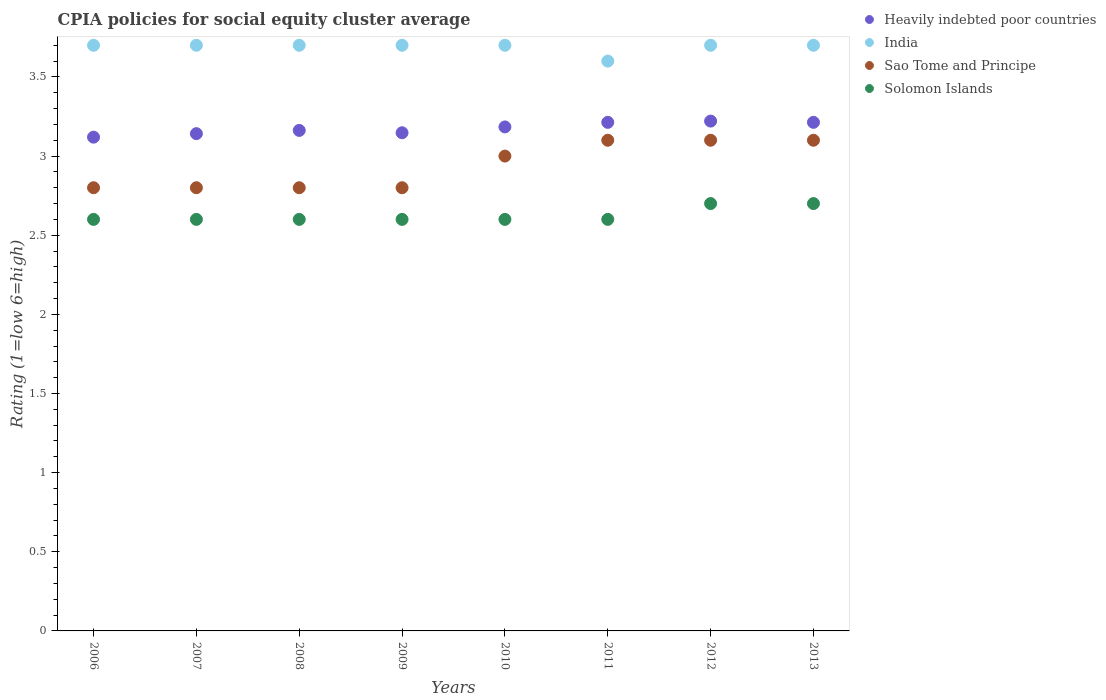Is the number of dotlines equal to the number of legend labels?
Your answer should be very brief. Yes. Across all years, what is the maximum CPIA rating in Heavily indebted poor countries?
Provide a succinct answer. 3.22. Across all years, what is the minimum CPIA rating in Solomon Islands?
Make the answer very short. 2.6. In which year was the CPIA rating in Heavily indebted poor countries maximum?
Your answer should be compact. 2012. What is the total CPIA rating in Solomon Islands in the graph?
Provide a short and direct response. 21. What is the difference between the CPIA rating in Solomon Islands in 2007 and that in 2011?
Your answer should be compact. 0. What is the difference between the CPIA rating in Sao Tome and Principe in 2011 and the CPIA rating in Solomon Islands in 2012?
Your answer should be very brief. 0.4. What is the average CPIA rating in India per year?
Offer a terse response. 3.69. In the year 2012, what is the difference between the CPIA rating in Solomon Islands and CPIA rating in Heavily indebted poor countries?
Your response must be concise. -0.52. What is the ratio of the CPIA rating in Sao Tome and Principe in 2008 to that in 2012?
Keep it short and to the point. 0.9. Is the CPIA rating in Sao Tome and Principe in 2009 less than that in 2013?
Provide a short and direct response. Yes. Is the difference between the CPIA rating in Solomon Islands in 2008 and 2011 greater than the difference between the CPIA rating in Heavily indebted poor countries in 2008 and 2011?
Keep it short and to the point. Yes. What is the difference between the highest and the lowest CPIA rating in Sao Tome and Principe?
Offer a terse response. 0.3. Is it the case that in every year, the sum of the CPIA rating in Solomon Islands and CPIA rating in India  is greater than the sum of CPIA rating in Sao Tome and Principe and CPIA rating in Heavily indebted poor countries?
Ensure brevity in your answer.  No. Is it the case that in every year, the sum of the CPIA rating in India and CPIA rating in Solomon Islands  is greater than the CPIA rating in Sao Tome and Principe?
Offer a terse response. Yes. Does the CPIA rating in Sao Tome and Principe monotonically increase over the years?
Your answer should be very brief. No. How many dotlines are there?
Offer a very short reply. 4. How many years are there in the graph?
Keep it short and to the point. 8. What is the difference between two consecutive major ticks on the Y-axis?
Keep it short and to the point. 0.5. How many legend labels are there?
Your answer should be very brief. 4. What is the title of the graph?
Give a very brief answer. CPIA policies for social equity cluster average. What is the label or title of the X-axis?
Provide a succinct answer. Years. What is the Rating (1=low 6=high) in Heavily indebted poor countries in 2006?
Ensure brevity in your answer.  3.12. What is the Rating (1=low 6=high) in Sao Tome and Principe in 2006?
Keep it short and to the point. 2.8. What is the Rating (1=low 6=high) of Heavily indebted poor countries in 2007?
Your response must be concise. 3.14. What is the Rating (1=low 6=high) in India in 2007?
Your response must be concise. 3.7. What is the Rating (1=low 6=high) in Solomon Islands in 2007?
Your response must be concise. 2.6. What is the Rating (1=low 6=high) of Heavily indebted poor countries in 2008?
Your answer should be very brief. 3.16. What is the Rating (1=low 6=high) of India in 2008?
Make the answer very short. 3.7. What is the Rating (1=low 6=high) of Sao Tome and Principe in 2008?
Give a very brief answer. 2.8. What is the Rating (1=low 6=high) in Solomon Islands in 2008?
Offer a terse response. 2.6. What is the Rating (1=low 6=high) in Heavily indebted poor countries in 2009?
Your answer should be compact. 3.15. What is the Rating (1=low 6=high) of Heavily indebted poor countries in 2010?
Offer a terse response. 3.18. What is the Rating (1=low 6=high) in Sao Tome and Principe in 2010?
Give a very brief answer. 3. What is the Rating (1=low 6=high) of Heavily indebted poor countries in 2011?
Provide a short and direct response. 3.21. What is the Rating (1=low 6=high) in India in 2011?
Keep it short and to the point. 3.6. What is the Rating (1=low 6=high) of Sao Tome and Principe in 2011?
Your response must be concise. 3.1. What is the Rating (1=low 6=high) in Heavily indebted poor countries in 2012?
Provide a succinct answer. 3.22. What is the Rating (1=low 6=high) of India in 2012?
Ensure brevity in your answer.  3.7. What is the Rating (1=low 6=high) in Heavily indebted poor countries in 2013?
Your answer should be very brief. 3.21. What is the Rating (1=low 6=high) of India in 2013?
Offer a terse response. 3.7. What is the Rating (1=low 6=high) of Sao Tome and Principe in 2013?
Ensure brevity in your answer.  3.1. Across all years, what is the maximum Rating (1=low 6=high) of Heavily indebted poor countries?
Keep it short and to the point. 3.22. Across all years, what is the maximum Rating (1=low 6=high) in India?
Provide a short and direct response. 3.7. Across all years, what is the maximum Rating (1=low 6=high) in Sao Tome and Principe?
Offer a terse response. 3.1. Across all years, what is the maximum Rating (1=low 6=high) of Solomon Islands?
Provide a short and direct response. 2.7. Across all years, what is the minimum Rating (1=low 6=high) of Heavily indebted poor countries?
Offer a terse response. 3.12. Across all years, what is the minimum Rating (1=low 6=high) in India?
Keep it short and to the point. 3.6. Across all years, what is the minimum Rating (1=low 6=high) in Sao Tome and Principe?
Your answer should be very brief. 2.8. What is the total Rating (1=low 6=high) of Heavily indebted poor countries in the graph?
Your answer should be very brief. 25.4. What is the total Rating (1=low 6=high) of India in the graph?
Keep it short and to the point. 29.5. What is the total Rating (1=low 6=high) of Sao Tome and Principe in the graph?
Make the answer very short. 23.5. What is the total Rating (1=low 6=high) of Solomon Islands in the graph?
Ensure brevity in your answer.  21. What is the difference between the Rating (1=low 6=high) in Heavily indebted poor countries in 2006 and that in 2007?
Make the answer very short. -0.02. What is the difference between the Rating (1=low 6=high) in Solomon Islands in 2006 and that in 2007?
Make the answer very short. 0. What is the difference between the Rating (1=low 6=high) of Heavily indebted poor countries in 2006 and that in 2008?
Offer a very short reply. -0.04. What is the difference between the Rating (1=low 6=high) in Solomon Islands in 2006 and that in 2008?
Your answer should be very brief. 0. What is the difference between the Rating (1=low 6=high) of Heavily indebted poor countries in 2006 and that in 2009?
Keep it short and to the point. -0.03. What is the difference between the Rating (1=low 6=high) in Heavily indebted poor countries in 2006 and that in 2010?
Offer a very short reply. -0.06. What is the difference between the Rating (1=low 6=high) in India in 2006 and that in 2010?
Offer a very short reply. 0. What is the difference between the Rating (1=low 6=high) in Heavily indebted poor countries in 2006 and that in 2011?
Make the answer very short. -0.09. What is the difference between the Rating (1=low 6=high) of Heavily indebted poor countries in 2006 and that in 2012?
Your response must be concise. -0.1. What is the difference between the Rating (1=low 6=high) of Sao Tome and Principe in 2006 and that in 2012?
Ensure brevity in your answer.  -0.3. What is the difference between the Rating (1=low 6=high) in Solomon Islands in 2006 and that in 2012?
Provide a short and direct response. -0.1. What is the difference between the Rating (1=low 6=high) in Heavily indebted poor countries in 2006 and that in 2013?
Offer a very short reply. -0.09. What is the difference between the Rating (1=low 6=high) in India in 2006 and that in 2013?
Your answer should be compact. 0. What is the difference between the Rating (1=low 6=high) of Heavily indebted poor countries in 2007 and that in 2008?
Offer a terse response. -0.02. What is the difference between the Rating (1=low 6=high) of India in 2007 and that in 2008?
Your answer should be compact. 0. What is the difference between the Rating (1=low 6=high) in Solomon Islands in 2007 and that in 2008?
Offer a very short reply. 0. What is the difference between the Rating (1=low 6=high) of Heavily indebted poor countries in 2007 and that in 2009?
Your response must be concise. -0.01. What is the difference between the Rating (1=low 6=high) of India in 2007 and that in 2009?
Your response must be concise. 0. What is the difference between the Rating (1=low 6=high) of Sao Tome and Principe in 2007 and that in 2009?
Keep it short and to the point. 0. What is the difference between the Rating (1=low 6=high) of Solomon Islands in 2007 and that in 2009?
Offer a very short reply. 0. What is the difference between the Rating (1=low 6=high) in Heavily indebted poor countries in 2007 and that in 2010?
Give a very brief answer. -0.04. What is the difference between the Rating (1=low 6=high) in India in 2007 and that in 2010?
Provide a succinct answer. 0. What is the difference between the Rating (1=low 6=high) of Sao Tome and Principe in 2007 and that in 2010?
Offer a terse response. -0.2. What is the difference between the Rating (1=low 6=high) in Solomon Islands in 2007 and that in 2010?
Keep it short and to the point. 0. What is the difference between the Rating (1=low 6=high) in Heavily indebted poor countries in 2007 and that in 2011?
Keep it short and to the point. -0.07. What is the difference between the Rating (1=low 6=high) in Sao Tome and Principe in 2007 and that in 2011?
Ensure brevity in your answer.  -0.3. What is the difference between the Rating (1=low 6=high) in Solomon Islands in 2007 and that in 2011?
Your response must be concise. 0. What is the difference between the Rating (1=low 6=high) in Heavily indebted poor countries in 2007 and that in 2012?
Offer a terse response. -0.08. What is the difference between the Rating (1=low 6=high) of Sao Tome and Principe in 2007 and that in 2012?
Your answer should be compact. -0.3. What is the difference between the Rating (1=low 6=high) in Heavily indebted poor countries in 2007 and that in 2013?
Offer a very short reply. -0.07. What is the difference between the Rating (1=low 6=high) of India in 2007 and that in 2013?
Give a very brief answer. 0. What is the difference between the Rating (1=low 6=high) in Sao Tome and Principe in 2007 and that in 2013?
Provide a succinct answer. -0.3. What is the difference between the Rating (1=low 6=high) in Solomon Islands in 2007 and that in 2013?
Provide a short and direct response. -0.1. What is the difference between the Rating (1=low 6=high) in Heavily indebted poor countries in 2008 and that in 2009?
Keep it short and to the point. 0.01. What is the difference between the Rating (1=low 6=high) of India in 2008 and that in 2009?
Give a very brief answer. 0. What is the difference between the Rating (1=low 6=high) of Sao Tome and Principe in 2008 and that in 2009?
Offer a terse response. 0. What is the difference between the Rating (1=low 6=high) in Solomon Islands in 2008 and that in 2009?
Provide a succinct answer. 0. What is the difference between the Rating (1=low 6=high) of Heavily indebted poor countries in 2008 and that in 2010?
Provide a succinct answer. -0.02. What is the difference between the Rating (1=low 6=high) of Sao Tome and Principe in 2008 and that in 2010?
Give a very brief answer. -0.2. What is the difference between the Rating (1=low 6=high) in Heavily indebted poor countries in 2008 and that in 2011?
Offer a terse response. -0.05. What is the difference between the Rating (1=low 6=high) in India in 2008 and that in 2011?
Make the answer very short. 0.1. What is the difference between the Rating (1=low 6=high) in Heavily indebted poor countries in 2008 and that in 2012?
Offer a very short reply. -0.06. What is the difference between the Rating (1=low 6=high) in Heavily indebted poor countries in 2008 and that in 2013?
Your response must be concise. -0.05. What is the difference between the Rating (1=low 6=high) in India in 2008 and that in 2013?
Offer a very short reply. 0. What is the difference between the Rating (1=low 6=high) of Sao Tome and Principe in 2008 and that in 2013?
Keep it short and to the point. -0.3. What is the difference between the Rating (1=low 6=high) in Heavily indebted poor countries in 2009 and that in 2010?
Provide a succinct answer. -0.04. What is the difference between the Rating (1=low 6=high) of India in 2009 and that in 2010?
Offer a very short reply. 0. What is the difference between the Rating (1=low 6=high) in Sao Tome and Principe in 2009 and that in 2010?
Offer a terse response. -0.2. What is the difference between the Rating (1=low 6=high) in Solomon Islands in 2009 and that in 2010?
Provide a short and direct response. 0. What is the difference between the Rating (1=low 6=high) in Heavily indebted poor countries in 2009 and that in 2011?
Your response must be concise. -0.07. What is the difference between the Rating (1=low 6=high) of Sao Tome and Principe in 2009 and that in 2011?
Your answer should be compact. -0.3. What is the difference between the Rating (1=low 6=high) of Solomon Islands in 2009 and that in 2011?
Offer a terse response. 0. What is the difference between the Rating (1=low 6=high) of Heavily indebted poor countries in 2009 and that in 2012?
Keep it short and to the point. -0.07. What is the difference between the Rating (1=low 6=high) of India in 2009 and that in 2012?
Ensure brevity in your answer.  0. What is the difference between the Rating (1=low 6=high) in Heavily indebted poor countries in 2009 and that in 2013?
Give a very brief answer. -0.07. What is the difference between the Rating (1=low 6=high) in Heavily indebted poor countries in 2010 and that in 2011?
Your response must be concise. -0.03. What is the difference between the Rating (1=low 6=high) in India in 2010 and that in 2011?
Provide a short and direct response. 0.1. What is the difference between the Rating (1=low 6=high) in Heavily indebted poor countries in 2010 and that in 2012?
Keep it short and to the point. -0.04. What is the difference between the Rating (1=low 6=high) of Sao Tome and Principe in 2010 and that in 2012?
Provide a succinct answer. -0.1. What is the difference between the Rating (1=low 6=high) in Solomon Islands in 2010 and that in 2012?
Your response must be concise. -0.1. What is the difference between the Rating (1=low 6=high) in Heavily indebted poor countries in 2010 and that in 2013?
Your response must be concise. -0.03. What is the difference between the Rating (1=low 6=high) of India in 2010 and that in 2013?
Your answer should be compact. 0. What is the difference between the Rating (1=low 6=high) of Solomon Islands in 2010 and that in 2013?
Offer a very short reply. -0.1. What is the difference between the Rating (1=low 6=high) of Heavily indebted poor countries in 2011 and that in 2012?
Offer a very short reply. -0.01. What is the difference between the Rating (1=low 6=high) in India in 2011 and that in 2012?
Make the answer very short. -0.1. What is the difference between the Rating (1=low 6=high) in Solomon Islands in 2011 and that in 2012?
Your answer should be very brief. -0.1. What is the difference between the Rating (1=low 6=high) in India in 2011 and that in 2013?
Offer a very short reply. -0.1. What is the difference between the Rating (1=low 6=high) of Solomon Islands in 2011 and that in 2013?
Your response must be concise. -0.1. What is the difference between the Rating (1=low 6=high) of Heavily indebted poor countries in 2012 and that in 2013?
Ensure brevity in your answer.  0.01. What is the difference between the Rating (1=low 6=high) in Sao Tome and Principe in 2012 and that in 2013?
Provide a short and direct response. 0. What is the difference between the Rating (1=low 6=high) of Heavily indebted poor countries in 2006 and the Rating (1=low 6=high) of India in 2007?
Make the answer very short. -0.58. What is the difference between the Rating (1=low 6=high) of Heavily indebted poor countries in 2006 and the Rating (1=low 6=high) of Sao Tome and Principe in 2007?
Ensure brevity in your answer.  0.32. What is the difference between the Rating (1=low 6=high) in Heavily indebted poor countries in 2006 and the Rating (1=low 6=high) in Solomon Islands in 2007?
Provide a succinct answer. 0.52. What is the difference between the Rating (1=low 6=high) of India in 2006 and the Rating (1=low 6=high) of Sao Tome and Principe in 2007?
Provide a succinct answer. 0.9. What is the difference between the Rating (1=low 6=high) in India in 2006 and the Rating (1=low 6=high) in Solomon Islands in 2007?
Offer a very short reply. 1.1. What is the difference between the Rating (1=low 6=high) of Heavily indebted poor countries in 2006 and the Rating (1=low 6=high) of India in 2008?
Provide a short and direct response. -0.58. What is the difference between the Rating (1=low 6=high) of Heavily indebted poor countries in 2006 and the Rating (1=low 6=high) of Sao Tome and Principe in 2008?
Your answer should be compact. 0.32. What is the difference between the Rating (1=low 6=high) of Heavily indebted poor countries in 2006 and the Rating (1=low 6=high) of Solomon Islands in 2008?
Your answer should be very brief. 0.52. What is the difference between the Rating (1=low 6=high) in India in 2006 and the Rating (1=low 6=high) in Sao Tome and Principe in 2008?
Make the answer very short. 0.9. What is the difference between the Rating (1=low 6=high) in Heavily indebted poor countries in 2006 and the Rating (1=low 6=high) in India in 2009?
Offer a very short reply. -0.58. What is the difference between the Rating (1=low 6=high) of Heavily indebted poor countries in 2006 and the Rating (1=low 6=high) of Sao Tome and Principe in 2009?
Offer a very short reply. 0.32. What is the difference between the Rating (1=low 6=high) of Heavily indebted poor countries in 2006 and the Rating (1=low 6=high) of Solomon Islands in 2009?
Make the answer very short. 0.52. What is the difference between the Rating (1=low 6=high) of India in 2006 and the Rating (1=low 6=high) of Solomon Islands in 2009?
Your response must be concise. 1.1. What is the difference between the Rating (1=low 6=high) in Sao Tome and Principe in 2006 and the Rating (1=low 6=high) in Solomon Islands in 2009?
Your answer should be very brief. 0.2. What is the difference between the Rating (1=low 6=high) in Heavily indebted poor countries in 2006 and the Rating (1=low 6=high) in India in 2010?
Your answer should be very brief. -0.58. What is the difference between the Rating (1=low 6=high) in Heavily indebted poor countries in 2006 and the Rating (1=low 6=high) in Sao Tome and Principe in 2010?
Offer a very short reply. 0.12. What is the difference between the Rating (1=low 6=high) of Heavily indebted poor countries in 2006 and the Rating (1=low 6=high) of Solomon Islands in 2010?
Your answer should be very brief. 0.52. What is the difference between the Rating (1=low 6=high) of India in 2006 and the Rating (1=low 6=high) of Sao Tome and Principe in 2010?
Make the answer very short. 0.7. What is the difference between the Rating (1=low 6=high) in Heavily indebted poor countries in 2006 and the Rating (1=low 6=high) in India in 2011?
Offer a terse response. -0.48. What is the difference between the Rating (1=low 6=high) of Heavily indebted poor countries in 2006 and the Rating (1=low 6=high) of Sao Tome and Principe in 2011?
Ensure brevity in your answer.  0.02. What is the difference between the Rating (1=low 6=high) in Heavily indebted poor countries in 2006 and the Rating (1=low 6=high) in Solomon Islands in 2011?
Make the answer very short. 0.52. What is the difference between the Rating (1=low 6=high) in Sao Tome and Principe in 2006 and the Rating (1=low 6=high) in Solomon Islands in 2011?
Your response must be concise. 0.2. What is the difference between the Rating (1=low 6=high) of Heavily indebted poor countries in 2006 and the Rating (1=low 6=high) of India in 2012?
Your answer should be compact. -0.58. What is the difference between the Rating (1=low 6=high) of Heavily indebted poor countries in 2006 and the Rating (1=low 6=high) of Sao Tome and Principe in 2012?
Your response must be concise. 0.02. What is the difference between the Rating (1=low 6=high) in Heavily indebted poor countries in 2006 and the Rating (1=low 6=high) in Solomon Islands in 2012?
Provide a succinct answer. 0.42. What is the difference between the Rating (1=low 6=high) of Heavily indebted poor countries in 2006 and the Rating (1=low 6=high) of India in 2013?
Offer a terse response. -0.58. What is the difference between the Rating (1=low 6=high) of Heavily indebted poor countries in 2006 and the Rating (1=low 6=high) of Sao Tome and Principe in 2013?
Make the answer very short. 0.02. What is the difference between the Rating (1=low 6=high) in Heavily indebted poor countries in 2006 and the Rating (1=low 6=high) in Solomon Islands in 2013?
Provide a succinct answer. 0.42. What is the difference between the Rating (1=low 6=high) of India in 2006 and the Rating (1=low 6=high) of Sao Tome and Principe in 2013?
Offer a very short reply. 0.6. What is the difference between the Rating (1=low 6=high) of India in 2006 and the Rating (1=low 6=high) of Solomon Islands in 2013?
Provide a succinct answer. 1. What is the difference between the Rating (1=low 6=high) of Heavily indebted poor countries in 2007 and the Rating (1=low 6=high) of India in 2008?
Your answer should be very brief. -0.56. What is the difference between the Rating (1=low 6=high) of Heavily indebted poor countries in 2007 and the Rating (1=low 6=high) of Sao Tome and Principe in 2008?
Your response must be concise. 0.34. What is the difference between the Rating (1=low 6=high) of Heavily indebted poor countries in 2007 and the Rating (1=low 6=high) of Solomon Islands in 2008?
Make the answer very short. 0.54. What is the difference between the Rating (1=low 6=high) in Heavily indebted poor countries in 2007 and the Rating (1=low 6=high) in India in 2009?
Your answer should be very brief. -0.56. What is the difference between the Rating (1=low 6=high) in Heavily indebted poor countries in 2007 and the Rating (1=low 6=high) in Sao Tome and Principe in 2009?
Offer a very short reply. 0.34. What is the difference between the Rating (1=low 6=high) of Heavily indebted poor countries in 2007 and the Rating (1=low 6=high) of Solomon Islands in 2009?
Make the answer very short. 0.54. What is the difference between the Rating (1=low 6=high) in Sao Tome and Principe in 2007 and the Rating (1=low 6=high) in Solomon Islands in 2009?
Your answer should be very brief. 0.2. What is the difference between the Rating (1=low 6=high) in Heavily indebted poor countries in 2007 and the Rating (1=low 6=high) in India in 2010?
Provide a succinct answer. -0.56. What is the difference between the Rating (1=low 6=high) in Heavily indebted poor countries in 2007 and the Rating (1=low 6=high) in Sao Tome and Principe in 2010?
Your answer should be compact. 0.14. What is the difference between the Rating (1=low 6=high) in Heavily indebted poor countries in 2007 and the Rating (1=low 6=high) in Solomon Islands in 2010?
Provide a succinct answer. 0.54. What is the difference between the Rating (1=low 6=high) of Sao Tome and Principe in 2007 and the Rating (1=low 6=high) of Solomon Islands in 2010?
Give a very brief answer. 0.2. What is the difference between the Rating (1=low 6=high) of Heavily indebted poor countries in 2007 and the Rating (1=low 6=high) of India in 2011?
Give a very brief answer. -0.46. What is the difference between the Rating (1=low 6=high) of Heavily indebted poor countries in 2007 and the Rating (1=low 6=high) of Sao Tome and Principe in 2011?
Provide a succinct answer. 0.04. What is the difference between the Rating (1=low 6=high) in Heavily indebted poor countries in 2007 and the Rating (1=low 6=high) in Solomon Islands in 2011?
Your response must be concise. 0.54. What is the difference between the Rating (1=low 6=high) of India in 2007 and the Rating (1=low 6=high) of Sao Tome and Principe in 2011?
Your answer should be compact. 0.6. What is the difference between the Rating (1=low 6=high) in Heavily indebted poor countries in 2007 and the Rating (1=low 6=high) in India in 2012?
Offer a very short reply. -0.56. What is the difference between the Rating (1=low 6=high) in Heavily indebted poor countries in 2007 and the Rating (1=low 6=high) in Sao Tome and Principe in 2012?
Offer a terse response. 0.04. What is the difference between the Rating (1=low 6=high) of Heavily indebted poor countries in 2007 and the Rating (1=low 6=high) of Solomon Islands in 2012?
Offer a very short reply. 0.44. What is the difference between the Rating (1=low 6=high) of India in 2007 and the Rating (1=low 6=high) of Sao Tome and Principe in 2012?
Your answer should be very brief. 0.6. What is the difference between the Rating (1=low 6=high) of India in 2007 and the Rating (1=low 6=high) of Solomon Islands in 2012?
Your response must be concise. 1. What is the difference between the Rating (1=low 6=high) in Heavily indebted poor countries in 2007 and the Rating (1=low 6=high) in India in 2013?
Your response must be concise. -0.56. What is the difference between the Rating (1=low 6=high) of Heavily indebted poor countries in 2007 and the Rating (1=low 6=high) of Sao Tome and Principe in 2013?
Give a very brief answer. 0.04. What is the difference between the Rating (1=low 6=high) in Heavily indebted poor countries in 2007 and the Rating (1=low 6=high) in Solomon Islands in 2013?
Ensure brevity in your answer.  0.44. What is the difference between the Rating (1=low 6=high) of India in 2007 and the Rating (1=low 6=high) of Solomon Islands in 2013?
Give a very brief answer. 1. What is the difference between the Rating (1=low 6=high) in Heavily indebted poor countries in 2008 and the Rating (1=low 6=high) in India in 2009?
Keep it short and to the point. -0.54. What is the difference between the Rating (1=low 6=high) in Heavily indebted poor countries in 2008 and the Rating (1=low 6=high) in Sao Tome and Principe in 2009?
Provide a succinct answer. 0.36. What is the difference between the Rating (1=low 6=high) in Heavily indebted poor countries in 2008 and the Rating (1=low 6=high) in Solomon Islands in 2009?
Offer a very short reply. 0.56. What is the difference between the Rating (1=low 6=high) in India in 2008 and the Rating (1=low 6=high) in Sao Tome and Principe in 2009?
Ensure brevity in your answer.  0.9. What is the difference between the Rating (1=low 6=high) in India in 2008 and the Rating (1=low 6=high) in Solomon Islands in 2009?
Give a very brief answer. 1.1. What is the difference between the Rating (1=low 6=high) in Heavily indebted poor countries in 2008 and the Rating (1=low 6=high) in India in 2010?
Keep it short and to the point. -0.54. What is the difference between the Rating (1=low 6=high) of Heavily indebted poor countries in 2008 and the Rating (1=low 6=high) of Sao Tome and Principe in 2010?
Offer a terse response. 0.16. What is the difference between the Rating (1=low 6=high) in Heavily indebted poor countries in 2008 and the Rating (1=low 6=high) in Solomon Islands in 2010?
Make the answer very short. 0.56. What is the difference between the Rating (1=low 6=high) of India in 2008 and the Rating (1=low 6=high) of Sao Tome and Principe in 2010?
Offer a terse response. 0.7. What is the difference between the Rating (1=low 6=high) of Heavily indebted poor countries in 2008 and the Rating (1=low 6=high) of India in 2011?
Your response must be concise. -0.44. What is the difference between the Rating (1=low 6=high) of Heavily indebted poor countries in 2008 and the Rating (1=low 6=high) of Sao Tome and Principe in 2011?
Offer a terse response. 0.06. What is the difference between the Rating (1=low 6=high) of Heavily indebted poor countries in 2008 and the Rating (1=low 6=high) of Solomon Islands in 2011?
Give a very brief answer. 0.56. What is the difference between the Rating (1=low 6=high) in India in 2008 and the Rating (1=low 6=high) in Solomon Islands in 2011?
Provide a succinct answer. 1.1. What is the difference between the Rating (1=low 6=high) of Heavily indebted poor countries in 2008 and the Rating (1=low 6=high) of India in 2012?
Offer a terse response. -0.54. What is the difference between the Rating (1=low 6=high) of Heavily indebted poor countries in 2008 and the Rating (1=low 6=high) of Sao Tome and Principe in 2012?
Your response must be concise. 0.06. What is the difference between the Rating (1=low 6=high) of Heavily indebted poor countries in 2008 and the Rating (1=low 6=high) of Solomon Islands in 2012?
Give a very brief answer. 0.46. What is the difference between the Rating (1=low 6=high) in Heavily indebted poor countries in 2008 and the Rating (1=low 6=high) in India in 2013?
Offer a very short reply. -0.54. What is the difference between the Rating (1=low 6=high) of Heavily indebted poor countries in 2008 and the Rating (1=low 6=high) of Sao Tome and Principe in 2013?
Keep it short and to the point. 0.06. What is the difference between the Rating (1=low 6=high) of Heavily indebted poor countries in 2008 and the Rating (1=low 6=high) of Solomon Islands in 2013?
Your answer should be compact. 0.46. What is the difference between the Rating (1=low 6=high) in India in 2008 and the Rating (1=low 6=high) in Solomon Islands in 2013?
Offer a terse response. 1. What is the difference between the Rating (1=low 6=high) of Sao Tome and Principe in 2008 and the Rating (1=low 6=high) of Solomon Islands in 2013?
Your answer should be very brief. 0.1. What is the difference between the Rating (1=low 6=high) of Heavily indebted poor countries in 2009 and the Rating (1=low 6=high) of India in 2010?
Your response must be concise. -0.55. What is the difference between the Rating (1=low 6=high) in Heavily indebted poor countries in 2009 and the Rating (1=low 6=high) in Sao Tome and Principe in 2010?
Give a very brief answer. 0.15. What is the difference between the Rating (1=low 6=high) in Heavily indebted poor countries in 2009 and the Rating (1=low 6=high) in Solomon Islands in 2010?
Make the answer very short. 0.55. What is the difference between the Rating (1=low 6=high) of India in 2009 and the Rating (1=low 6=high) of Sao Tome and Principe in 2010?
Ensure brevity in your answer.  0.7. What is the difference between the Rating (1=low 6=high) of Heavily indebted poor countries in 2009 and the Rating (1=low 6=high) of India in 2011?
Offer a very short reply. -0.45. What is the difference between the Rating (1=low 6=high) in Heavily indebted poor countries in 2009 and the Rating (1=low 6=high) in Sao Tome and Principe in 2011?
Your answer should be very brief. 0.05. What is the difference between the Rating (1=low 6=high) of Heavily indebted poor countries in 2009 and the Rating (1=low 6=high) of Solomon Islands in 2011?
Give a very brief answer. 0.55. What is the difference between the Rating (1=low 6=high) in Heavily indebted poor countries in 2009 and the Rating (1=low 6=high) in India in 2012?
Provide a short and direct response. -0.55. What is the difference between the Rating (1=low 6=high) of Heavily indebted poor countries in 2009 and the Rating (1=low 6=high) of Sao Tome and Principe in 2012?
Your response must be concise. 0.05. What is the difference between the Rating (1=low 6=high) of Heavily indebted poor countries in 2009 and the Rating (1=low 6=high) of Solomon Islands in 2012?
Keep it short and to the point. 0.45. What is the difference between the Rating (1=low 6=high) in India in 2009 and the Rating (1=low 6=high) in Sao Tome and Principe in 2012?
Keep it short and to the point. 0.6. What is the difference between the Rating (1=low 6=high) in India in 2009 and the Rating (1=low 6=high) in Solomon Islands in 2012?
Provide a short and direct response. 1. What is the difference between the Rating (1=low 6=high) in Sao Tome and Principe in 2009 and the Rating (1=low 6=high) in Solomon Islands in 2012?
Ensure brevity in your answer.  0.1. What is the difference between the Rating (1=low 6=high) of Heavily indebted poor countries in 2009 and the Rating (1=low 6=high) of India in 2013?
Your answer should be compact. -0.55. What is the difference between the Rating (1=low 6=high) in Heavily indebted poor countries in 2009 and the Rating (1=low 6=high) in Sao Tome and Principe in 2013?
Your answer should be compact. 0.05. What is the difference between the Rating (1=low 6=high) in Heavily indebted poor countries in 2009 and the Rating (1=low 6=high) in Solomon Islands in 2013?
Offer a very short reply. 0.45. What is the difference between the Rating (1=low 6=high) of India in 2009 and the Rating (1=low 6=high) of Sao Tome and Principe in 2013?
Keep it short and to the point. 0.6. What is the difference between the Rating (1=low 6=high) in India in 2009 and the Rating (1=low 6=high) in Solomon Islands in 2013?
Ensure brevity in your answer.  1. What is the difference between the Rating (1=low 6=high) in Heavily indebted poor countries in 2010 and the Rating (1=low 6=high) in India in 2011?
Make the answer very short. -0.42. What is the difference between the Rating (1=low 6=high) of Heavily indebted poor countries in 2010 and the Rating (1=low 6=high) of Sao Tome and Principe in 2011?
Offer a very short reply. 0.08. What is the difference between the Rating (1=low 6=high) of Heavily indebted poor countries in 2010 and the Rating (1=low 6=high) of Solomon Islands in 2011?
Offer a very short reply. 0.58. What is the difference between the Rating (1=low 6=high) in India in 2010 and the Rating (1=low 6=high) in Solomon Islands in 2011?
Your answer should be very brief. 1.1. What is the difference between the Rating (1=low 6=high) in Heavily indebted poor countries in 2010 and the Rating (1=low 6=high) in India in 2012?
Offer a very short reply. -0.52. What is the difference between the Rating (1=low 6=high) in Heavily indebted poor countries in 2010 and the Rating (1=low 6=high) in Sao Tome and Principe in 2012?
Keep it short and to the point. 0.08. What is the difference between the Rating (1=low 6=high) in Heavily indebted poor countries in 2010 and the Rating (1=low 6=high) in Solomon Islands in 2012?
Your answer should be very brief. 0.48. What is the difference between the Rating (1=low 6=high) in India in 2010 and the Rating (1=low 6=high) in Solomon Islands in 2012?
Make the answer very short. 1. What is the difference between the Rating (1=low 6=high) of Heavily indebted poor countries in 2010 and the Rating (1=low 6=high) of India in 2013?
Your answer should be compact. -0.52. What is the difference between the Rating (1=low 6=high) of Heavily indebted poor countries in 2010 and the Rating (1=low 6=high) of Sao Tome and Principe in 2013?
Provide a short and direct response. 0.08. What is the difference between the Rating (1=low 6=high) in Heavily indebted poor countries in 2010 and the Rating (1=low 6=high) in Solomon Islands in 2013?
Keep it short and to the point. 0.48. What is the difference between the Rating (1=low 6=high) of India in 2010 and the Rating (1=low 6=high) of Solomon Islands in 2013?
Your answer should be compact. 1. What is the difference between the Rating (1=low 6=high) of Sao Tome and Principe in 2010 and the Rating (1=low 6=high) of Solomon Islands in 2013?
Ensure brevity in your answer.  0.3. What is the difference between the Rating (1=low 6=high) in Heavily indebted poor countries in 2011 and the Rating (1=low 6=high) in India in 2012?
Provide a succinct answer. -0.49. What is the difference between the Rating (1=low 6=high) in Heavily indebted poor countries in 2011 and the Rating (1=low 6=high) in Sao Tome and Principe in 2012?
Make the answer very short. 0.11. What is the difference between the Rating (1=low 6=high) in Heavily indebted poor countries in 2011 and the Rating (1=low 6=high) in Solomon Islands in 2012?
Your answer should be compact. 0.51. What is the difference between the Rating (1=low 6=high) of Sao Tome and Principe in 2011 and the Rating (1=low 6=high) of Solomon Islands in 2012?
Your response must be concise. 0.4. What is the difference between the Rating (1=low 6=high) in Heavily indebted poor countries in 2011 and the Rating (1=low 6=high) in India in 2013?
Provide a succinct answer. -0.49. What is the difference between the Rating (1=low 6=high) in Heavily indebted poor countries in 2011 and the Rating (1=low 6=high) in Sao Tome and Principe in 2013?
Your answer should be compact. 0.11. What is the difference between the Rating (1=low 6=high) in Heavily indebted poor countries in 2011 and the Rating (1=low 6=high) in Solomon Islands in 2013?
Offer a terse response. 0.51. What is the difference between the Rating (1=low 6=high) of India in 2011 and the Rating (1=low 6=high) of Sao Tome and Principe in 2013?
Your answer should be very brief. 0.5. What is the difference between the Rating (1=low 6=high) of India in 2011 and the Rating (1=low 6=high) of Solomon Islands in 2013?
Keep it short and to the point. 0.9. What is the difference between the Rating (1=low 6=high) in Sao Tome and Principe in 2011 and the Rating (1=low 6=high) in Solomon Islands in 2013?
Give a very brief answer. 0.4. What is the difference between the Rating (1=low 6=high) of Heavily indebted poor countries in 2012 and the Rating (1=low 6=high) of India in 2013?
Your response must be concise. -0.48. What is the difference between the Rating (1=low 6=high) of Heavily indebted poor countries in 2012 and the Rating (1=low 6=high) of Sao Tome and Principe in 2013?
Keep it short and to the point. 0.12. What is the difference between the Rating (1=low 6=high) in Heavily indebted poor countries in 2012 and the Rating (1=low 6=high) in Solomon Islands in 2013?
Your answer should be compact. 0.52. What is the difference between the Rating (1=low 6=high) in Sao Tome and Principe in 2012 and the Rating (1=low 6=high) in Solomon Islands in 2013?
Ensure brevity in your answer.  0.4. What is the average Rating (1=low 6=high) in Heavily indebted poor countries per year?
Make the answer very short. 3.18. What is the average Rating (1=low 6=high) of India per year?
Provide a succinct answer. 3.69. What is the average Rating (1=low 6=high) in Sao Tome and Principe per year?
Make the answer very short. 2.94. What is the average Rating (1=low 6=high) of Solomon Islands per year?
Ensure brevity in your answer.  2.62. In the year 2006, what is the difference between the Rating (1=low 6=high) of Heavily indebted poor countries and Rating (1=low 6=high) of India?
Give a very brief answer. -0.58. In the year 2006, what is the difference between the Rating (1=low 6=high) of Heavily indebted poor countries and Rating (1=low 6=high) of Sao Tome and Principe?
Give a very brief answer. 0.32. In the year 2006, what is the difference between the Rating (1=low 6=high) of Heavily indebted poor countries and Rating (1=low 6=high) of Solomon Islands?
Keep it short and to the point. 0.52. In the year 2006, what is the difference between the Rating (1=low 6=high) of India and Rating (1=low 6=high) of Solomon Islands?
Your response must be concise. 1.1. In the year 2006, what is the difference between the Rating (1=low 6=high) in Sao Tome and Principe and Rating (1=low 6=high) in Solomon Islands?
Offer a terse response. 0.2. In the year 2007, what is the difference between the Rating (1=low 6=high) in Heavily indebted poor countries and Rating (1=low 6=high) in India?
Keep it short and to the point. -0.56. In the year 2007, what is the difference between the Rating (1=low 6=high) of Heavily indebted poor countries and Rating (1=low 6=high) of Sao Tome and Principe?
Make the answer very short. 0.34. In the year 2007, what is the difference between the Rating (1=low 6=high) of Heavily indebted poor countries and Rating (1=low 6=high) of Solomon Islands?
Your response must be concise. 0.54. In the year 2007, what is the difference between the Rating (1=low 6=high) in India and Rating (1=low 6=high) in Solomon Islands?
Offer a terse response. 1.1. In the year 2007, what is the difference between the Rating (1=low 6=high) in Sao Tome and Principe and Rating (1=low 6=high) in Solomon Islands?
Provide a succinct answer. 0.2. In the year 2008, what is the difference between the Rating (1=low 6=high) in Heavily indebted poor countries and Rating (1=low 6=high) in India?
Offer a terse response. -0.54. In the year 2008, what is the difference between the Rating (1=low 6=high) in Heavily indebted poor countries and Rating (1=low 6=high) in Sao Tome and Principe?
Ensure brevity in your answer.  0.36. In the year 2008, what is the difference between the Rating (1=low 6=high) in Heavily indebted poor countries and Rating (1=low 6=high) in Solomon Islands?
Your answer should be very brief. 0.56. In the year 2009, what is the difference between the Rating (1=low 6=high) of Heavily indebted poor countries and Rating (1=low 6=high) of India?
Give a very brief answer. -0.55. In the year 2009, what is the difference between the Rating (1=low 6=high) of Heavily indebted poor countries and Rating (1=low 6=high) of Sao Tome and Principe?
Offer a very short reply. 0.35. In the year 2009, what is the difference between the Rating (1=low 6=high) of Heavily indebted poor countries and Rating (1=low 6=high) of Solomon Islands?
Make the answer very short. 0.55. In the year 2009, what is the difference between the Rating (1=low 6=high) of India and Rating (1=low 6=high) of Sao Tome and Principe?
Your response must be concise. 0.9. In the year 2009, what is the difference between the Rating (1=low 6=high) of India and Rating (1=low 6=high) of Solomon Islands?
Your response must be concise. 1.1. In the year 2009, what is the difference between the Rating (1=low 6=high) in Sao Tome and Principe and Rating (1=low 6=high) in Solomon Islands?
Your answer should be compact. 0.2. In the year 2010, what is the difference between the Rating (1=low 6=high) in Heavily indebted poor countries and Rating (1=low 6=high) in India?
Offer a very short reply. -0.52. In the year 2010, what is the difference between the Rating (1=low 6=high) in Heavily indebted poor countries and Rating (1=low 6=high) in Sao Tome and Principe?
Make the answer very short. 0.18. In the year 2010, what is the difference between the Rating (1=low 6=high) of Heavily indebted poor countries and Rating (1=low 6=high) of Solomon Islands?
Offer a terse response. 0.58. In the year 2010, what is the difference between the Rating (1=low 6=high) of India and Rating (1=low 6=high) of Sao Tome and Principe?
Provide a succinct answer. 0.7. In the year 2010, what is the difference between the Rating (1=low 6=high) in India and Rating (1=low 6=high) in Solomon Islands?
Give a very brief answer. 1.1. In the year 2010, what is the difference between the Rating (1=low 6=high) in Sao Tome and Principe and Rating (1=low 6=high) in Solomon Islands?
Your response must be concise. 0.4. In the year 2011, what is the difference between the Rating (1=low 6=high) of Heavily indebted poor countries and Rating (1=low 6=high) of India?
Ensure brevity in your answer.  -0.39. In the year 2011, what is the difference between the Rating (1=low 6=high) in Heavily indebted poor countries and Rating (1=low 6=high) in Sao Tome and Principe?
Your response must be concise. 0.11. In the year 2011, what is the difference between the Rating (1=low 6=high) in Heavily indebted poor countries and Rating (1=low 6=high) in Solomon Islands?
Your answer should be compact. 0.61. In the year 2011, what is the difference between the Rating (1=low 6=high) of India and Rating (1=low 6=high) of Sao Tome and Principe?
Make the answer very short. 0.5. In the year 2012, what is the difference between the Rating (1=low 6=high) of Heavily indebted poor countries and Rating (1=low 6=high) of India?
Give a very brief answer. -0.48. In the year 2012, what is the difference between the Rating (1=low 6=high) of Heavily indebted poor countries and Rating (1=low 6=high) of Sao Tome and Principe?
Keep it short and to the point. 0.12. In the year 2012, what is the difference between the Rating (1=low 6=high) in Heavily indebted poor countries and Rating (1=low 6=high) in Solomon Islands?
Offer a terse response. 0.52. In the year 2012, what is the difference between the Rating (1=low 6=high) in India and Rating (1=low 6=high) in Solomon Islands?
Your answer should be very brief. 1. In the year 2013, what is the difference between the Rating (1=low 6=high) of Heavily indebted poor countries and Rating (1=low 6=high) of India?
Keep it short and to the point. -0.49. In the year 2013, what is the difference between the Rating (1=low 6=high) of Heavily indebted poor countries and Rating (1=low 6=high) of Sao Tome and Principe?
Your answer should be compact. 0.11. In the year 2013, what is the difference between the Rating (1=low 6=high) of Heavily indebted poor countries and Rating (1=low 6=high) of Solomon Islands?
Keep it short and to the point. 0.51. In the year 2013, what is the difference between the Rating (1=low 6=high) in India and Rating (1=low 6=high) in Sao Tome and Principe?
Give a very brief answer. 0.6. In the year 2013, what is the difference between the Rating (1=low 6=high) of Sao Tome and Principe and Rating (1=low 6=high) of Solomon Islands?
Your answer should be very brief. 0.4. What is the ratio of the Rating (1=low 6=high) in Heavily indebted poor countries in 2006 to that in 2007?
Provide a short and direct response. 0.99. What is the ratio of the Rating (1=low 6=high) of Solomon Islands in 2006 to that in 2007?
Your answer should be compact. 1. What is the ratio of the Rating (1=low 6=high) in Heavily indebted poor countries in 2006 to that in 2008?
Provide a succinct answer. 0.99. What is the ratio of the Rating (1=low 6=high) in Sao Tome and Principe in 2006 to that in 2008?
Ensure brevity in your answer.  1. What is the ratio of the Rating (1=low 6=high) in Sao Tome and Principe in 2006 to that in 2009?
Your response must be concise. 1. What is the ratio of the Rating (1=low 6=high) in Solomon Islands in 2006 to that in 2009?
Your answer should be compact. 1. What is the ratio of the Rating (1=low 6=high) in Heavily indebted poor countries in 2006 to that in 2010?
Your answer should be very brief. 0.98. What is the ratio of the Rating (1=low 6=high) of Sao Tome and Principe in 2006 to that in 2010?
Ensure brevity in your answer.  0.93. What is the ratio of the Rating (1=low 6=high) in Solomon Islands in 2006 to that in 2010?
Give a very brief answer. 1. What is the ratio of the Rating (1=low 6=high) of Heavily indebted poor countries in 2006 to that in 2011?
Your answer should be very brief. 0.97. What is the ratio of the Rating (1=low 6=high) of India in 2006 to that in 2011?
Your answer should be very brief. 1.03. What is the ratio of the Rating (1=low 6=high) of Sao Tome and Principe in 2006 to that in 2011?
Your response must be concise. 0.9. What is the ratio of the Rating (1=low 6=high) of Solomon Islands in 2006 to that in 2011?
Provide a short and direct response. 1. What is the ratio of the Rating (1=low 6=high) of Heavily indebted poor countries in 2006 to that in 2012?
Offer a terse response. 0.97. What is the ratio of the Rating (1=low 6=high) of Sao Tome and Principe in 2006 to that in 2012?
Give a very brief answer. 0.9. What is the ratio of the Rating (1=low 6=high) in Solomon Islands in 2006 to that in 2012?
Make the answer very short. 0.96. What is the ratio of the Rating (1=low 6=high) in Heavily indebted poor countries in 2006 to that in 2013?
Your response must be concise. 0.97. What is the ratio of the Rating (1=low 6=high) in India in 2006 to that in 2013?
Your answer should be compact. 1. What is the ratio of the Rating (1=low 6=high) in Sao Tome and Principe in 2006 to that in 2013?
Make the answer very short. 0.9. What is the ratio of the Rating (1=low 6=high) of Heavily indebted poor countries in 2007 to that in 2008?
Offer a very short reply. 0.99. What is the ratio of the Rating (1=low 6=high) of India in 2007 to that in 2008?
Provide a short and direct response. 1. What is the ratio of the Rating (1=low 6=high) in Sao Tome and Principe in 2007 to that in 2008?
Provide a short and direct response. 1. What is the ratio of the Rating (1=low 6=high) of Heavily indebted poor countries in 2007 to that in 2009?
Ensure brevity in your answer.  1. What is the ratio of the Rating (1=low 6=high) in India in 2007 to that in 2009?
Offer a terse response. 1. What is the ratio of the Rating (1=low 6=high) in Sao Tome and Principe in 2007 to that in 2009?
Offer a terse response. 1. What is the ratio of the Rating (1=low 6=high) in Solomon Islands in 2007 to that in 2009?
Your response must be concise. 1. What is the ratio of the Rating (1=low 6=high) in Heavily indebted poor countries in 2007 to that in 2010?
Make the answer very short. 0.99. What is the ratio of the Rating (1=low 6=high) in India in 2007 to that in 2010?
Give a very brief answer. 1. What is the ratio of the Rating (1=low 6=high) of Heavily indebted poor countries in 2007 to that in 2011?
Offer a very short reply. 0.98. What is the ratio of the Rating (1=low 6=high) in India in 2007 to that in 2011?
Your answer should be compact. 1.03. What is the ratio of the Rating (1=low 6=high) of Sao Tome and Principe in 2007 to that in 2011?
Keep it short and to the point. 0.9. What is the ratio of the Rating (1=low 6=high) in Solomon Islands in 2007 to that in 2011?
Your answer should be very brief. 1. What is the ratio of the Rating (1=low 6=high) in Heavily indebted poor countries in 2007 to that in 2012?
Offer a terse response. 0.98. What is the ratio of the Rating (1=low 6=high) in Sao Tome and Principe in 2007 to that in 2012?
Offer a terse response. 0.9. What is the ratio of the Rating (1=low 6=high) in Solomon Islands in 2007 to that in 2012?
Ensure brevity in your answer.  0.96. What is the ratio of the Rating (1=low 6=high) in Heavily indebted poor countries in 2007 to that in 2013?
Your answer should be compact. 0.98. What is the ratio of the Rating (1=low 6=high) in India in 2007 to that in 2013?
Provide a succinct answer. 1. What is the ratio of the Rating (1=low 6=high) in Sao Tome and Principe in 2007 to that in 2013?
Provide a short and direct response. 0.9. What is the ratio of the Rating (1=low 6=high) in Solomon Islands in 2007 to that in 2013?
Your answer should be compact. 0.96. What is the ratio of the Rating (1=low 6=high) in Heavily indebted poor countries in 2008 to that in 2009?
Ensure brevity in your answer.  1. What is the ratio of the Rating (1=low 6=high) in India in 2008 to that in 2009?
Ensure brevity in your answer.  1. What is the ratio of the Rating (1=low 6=high) in Sao Tome and Principe in 2008 to that in 2009?
Offer a very short reply. 1. What is the ratio of the Rating (1=low 6=high) in India in 2008 to that in 2010?
Make the answer very short. 1. What is the ratio of the Rating (1=low 6=high) in Sao Tome and Principe in 2008 to that in 2010?
Ensure brevity in your answer.  0.93. What is the ratio of the Rating (1=low 6=high) in Heavily indebted poor countries in 2008 to that in 2011?
Make the answer very short. 0.98. What is the ratio of the Rating (1=low 6=high) of India in 2008 to that in 2011?
Ensure brevity in your answer.  1.03. What is the ratio of the Rating (1=low 6=high) of Sao Tome and Principe in 2008 to that in 2011?
Give a very brief answer. 0.9. What is the ratio of the Rating (1=low 6=high) of Heavily indebted poor countries in 2008 to that in 2012?
Your answer should be very brief. 0.98. What is the ratio of the Rating (1=low 6=high) of Sao Tome and Principe in 2008 to that in 2012?
Give a very brief answer. 0.9. What is the ratio of the Rating (1=low 6=high) in Heavily indebted poor countries in 2008 to that in 2013?
Your answer should be compact. 0.98. What is the ratio of the Rating (1=low 6=high) in India in 2008 to that in 2013?
Keep it short and to the point. 1. What is the ratio of the Rating (1=low 6=high) of Sao Tome and Principe in 2008 to that in 2013?
Keep it short and to the point. 0.9. What is the ratio of the Rating (1=low 6=high) of Heavily indebted poor countries in 2009 to that in 2010?
Make the answer very short. 0.99. What is the ratio of the Rating (1=low 6=high) of Solomon Islands in 2009 to that in 2010?
Make the answer very short. 1. What is the ratio of the Rating (1=low 6=high) in Heavily indebted poor countries in 2009 to that in 2011?
Your answer should be very brief. 0.98. What is the ratio of the Rating (1=low 6=high) in India in 2009 to that in 2011?
Keep it short and to the point. 1.03. What is the ratio of the Rating (1=low 6=high) in Sao Tome and Principe in 2009 to that in 2011?
Offer a terse response. 0.9. What is the ratio of the Rating (1=low 6=high) in Solomon Islands in 2009 to that in 2011?
Your answer should be very brief. 1. What is the ratio of the Rating (1=low 6=high) in Heavily indebted poor countries in 2009 to that in 2012?
Ensure brevity in your answer.  0.98. What is the ratio of the Rating (1=low 6=high) in India in 2009 to that in 2012?
Provide a short and direct response. 1. What is the ratio of the Rating (1=low 6=high) in Sao Tome and Principe in 2009 to that in 2012?
Your answer should be very brief. 0.9. What is the ratio of the Rating (1=low 6=high) of Solomon Islands in 2009 to that in 2012?
Offer a terse response. 0.96. What is the ratio of the Rating (1=low 6=high) of Heavily indebted poor countries in 2009 to that in 2013?
Offer a very short reply. 0.98. What is the ratio of the Rating (1=low 6=high) in Sao Tome and Principe in 2009 to that in 2013?
Provide a succinct answer. 0.9. What is the ratio of the Rating (1=low 6=high) in Solomon Islands in 2009 to that in 2013?
Offer a very short reply. 0.96. What is the ratio of the Rating (1=low 6=high) in Heavily indebted poor countries in 2010 to that in 2011?
Offer a very short reply. 0.99. What is the ratio of the Rating (1=low 6=high) of India in 2010 to that in 2011?
Your response must be concise. 1.03. What is the ratio of the Rating (1=low 6=high) of Sao Tome and Principe in 2010 to that in 2012?
Your answer should be very brief. 0.97. What is the ratio of the Rating (1=low 6=high) in Solomon Islands in 2010 to that in 2012?
Your answer should be very brief. 0.96. What is the ratio of the Rating (1=low 6=high) in India in 2010 to that in 2013?
Give a very brief answer. 1. What is the ratio of the Rating (1=low 6=high) in Sao Tome and Principe in 2010 to that in 2013?
Your answer should be very brief. 0.97. What is the ratio of the Rating (1=low 6=high) in Heavily indebted poor countries in 2011 to that in 2012?
Offer a terse response. 1. What is the ratio of the Rating (1=low 6=high) of India in 2011 to that in 2012?
Offer a terse response. 0.97. What is the ratio of the Rating (1=low 6=high) in Sao Tome and Principe in 2011 to that in 2012?
Keep it short and to the point. 1. What is the ratio of the Rating (1=low 6=high) in Solomon Islands in 2011 to that in 2012?
Keep it short and to the point. 0.96. What is the ratio of the Rating (1=low 6=high) of India in 2011 to that in 2013?
Keep it short and to the point. 0.97. What is the ratio of the Rating (1=low 6=high) of Sao Tome and Principe in 2011 to that in 2013?
Make the answer very short. 1. What is the ratio of the Rating (1=low 6=high) in Solomon Islands in 2011 to that in 2013?
Give a very brief answer. 0.96. What is the ratio of the Rating (1=low 6=high) of Heavily indebted poor countries in 2012 to that in 2013?
Ensure brevity in your answer.  1. What is the ratio of the Rating (1=low 6=high) of India in 2012 to that in 2013?
Provide a short and direct response. 1. What is the ratio of the Rating (1=low 6=high) in Sao Tome and Principe in 2012 to that in 2013?
Provide a short and direct response. 1. What is the difference between the highest and the second highest Rating (1=low 6=high) in Heavily indebted poor countries?
Offer a terse response. 0.01. What is the difference between the highest and the second highest Rating (1=low 6=high) in India?
Ensure brevity in your answer.  0. What is the difference between the highest and the second highest Rating (1=low 6=high) of Sao Tome and Principe?
Ensure brevity in your answer.  0. What is the difference between the highest and the lowest Rating (1=low 6=high) in Heavily indebted poor countries?
Your response must be concise. 0.1. What is the difference between the highest and the lowest Rating (1=low 6=high) of India?
Offer a terse response. 0.1. What is the difference between the highest and the lowest Rating (1=low 6=high) of Sao Tome and Principe?
Ensure brevity in your answer.  0.3. What is the difference between the highest and the lowest Rating (1=low 6=high) of Solomon Islands?
Make the answer very short. 0.1. 